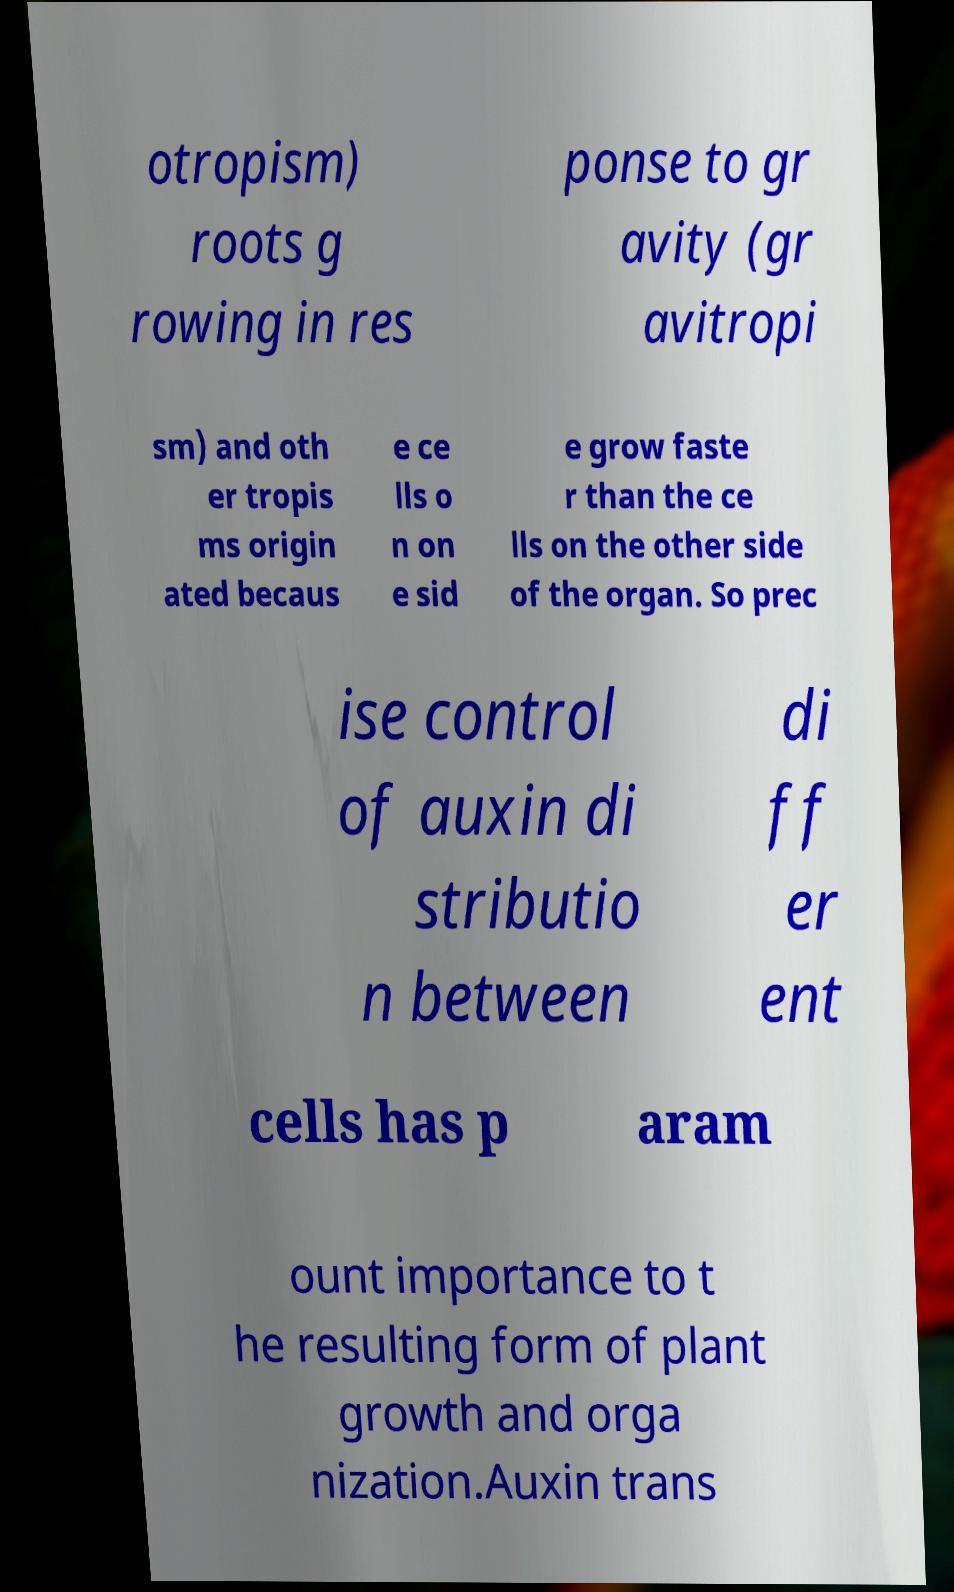Could you assist in decoding the text presented in this image and type it out clearly? otropism) roots g rowing in res ponse to gr avity (gr avitropi sm) and oth er tropis ms origin ated becaus e ce lls o n on e sid e grow faste r than the ce lls on the other side of the organ. So prec ise control of auxin di stributio n between di ff er ent cells has p aram ount importance to t he resulting form of plant growth and orga nization.Auxin trans 